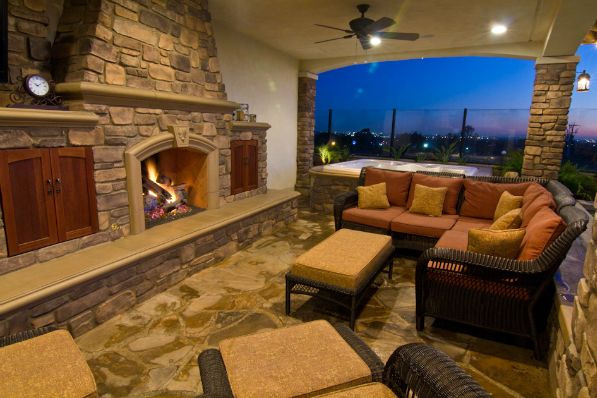Can you describe the style and elements of the patio's design? Certainly! The patio has a rustic yet elegant design, featuring a stone fireplace as the focal point. The seating includes a plush sofa set with a mix of chairs around a central coffee table, all in coordinating dark wicker material. The flooring is natural stone, which complements the stonework of the fireplace. There are wooden cabinets with a traditional style on either side of the fireplace, and atmospheric lighting provided by the fireplace, overhead fan light, and subtle wall fixtures. The open view of the sky and distant lights suggests this is an elevated outdoor space, ideal for relaxation or social gatherings in the evening. 